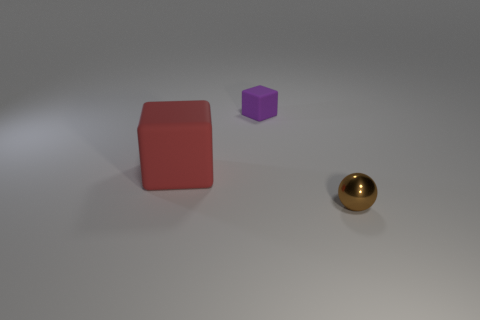Are there any other things that are the same material as the sphere?
Offer a terse response. No. How many red rubber things are the same shape as the brown object?
Your answer should be compact. 0. What is the shape of the purple rubber thing that is the same size as the brown metallic object?
Your answer should be very brief. Cube. Are there any red rubber things right of the red rubber cube?
Give a very brief answer. No. There is a small thing that is left of the small brown metallic sphere; is there a red thing that is on the right side of it?
Make the answer very short. No. Is the number of big rubber objects that are on the right side of the big red rubber object less than the number of small brown metallic objects that are on the left side of the shiny object?
Offer a very short reply. No. Is there anything else that is the same size as the red matte block?
Your answer should be very brief. No. The metal object has what shape?
Your answer should be compact. Sphere. What material is the object that is on the right side of the small purple rubber thing?
Ensure brevity in your answer.  Metal. There is a block on the right side of the rubber object that is on the left side of the matte object that is behind the big red matte cube; how big is it?
Your answer should be very brief. Small. 